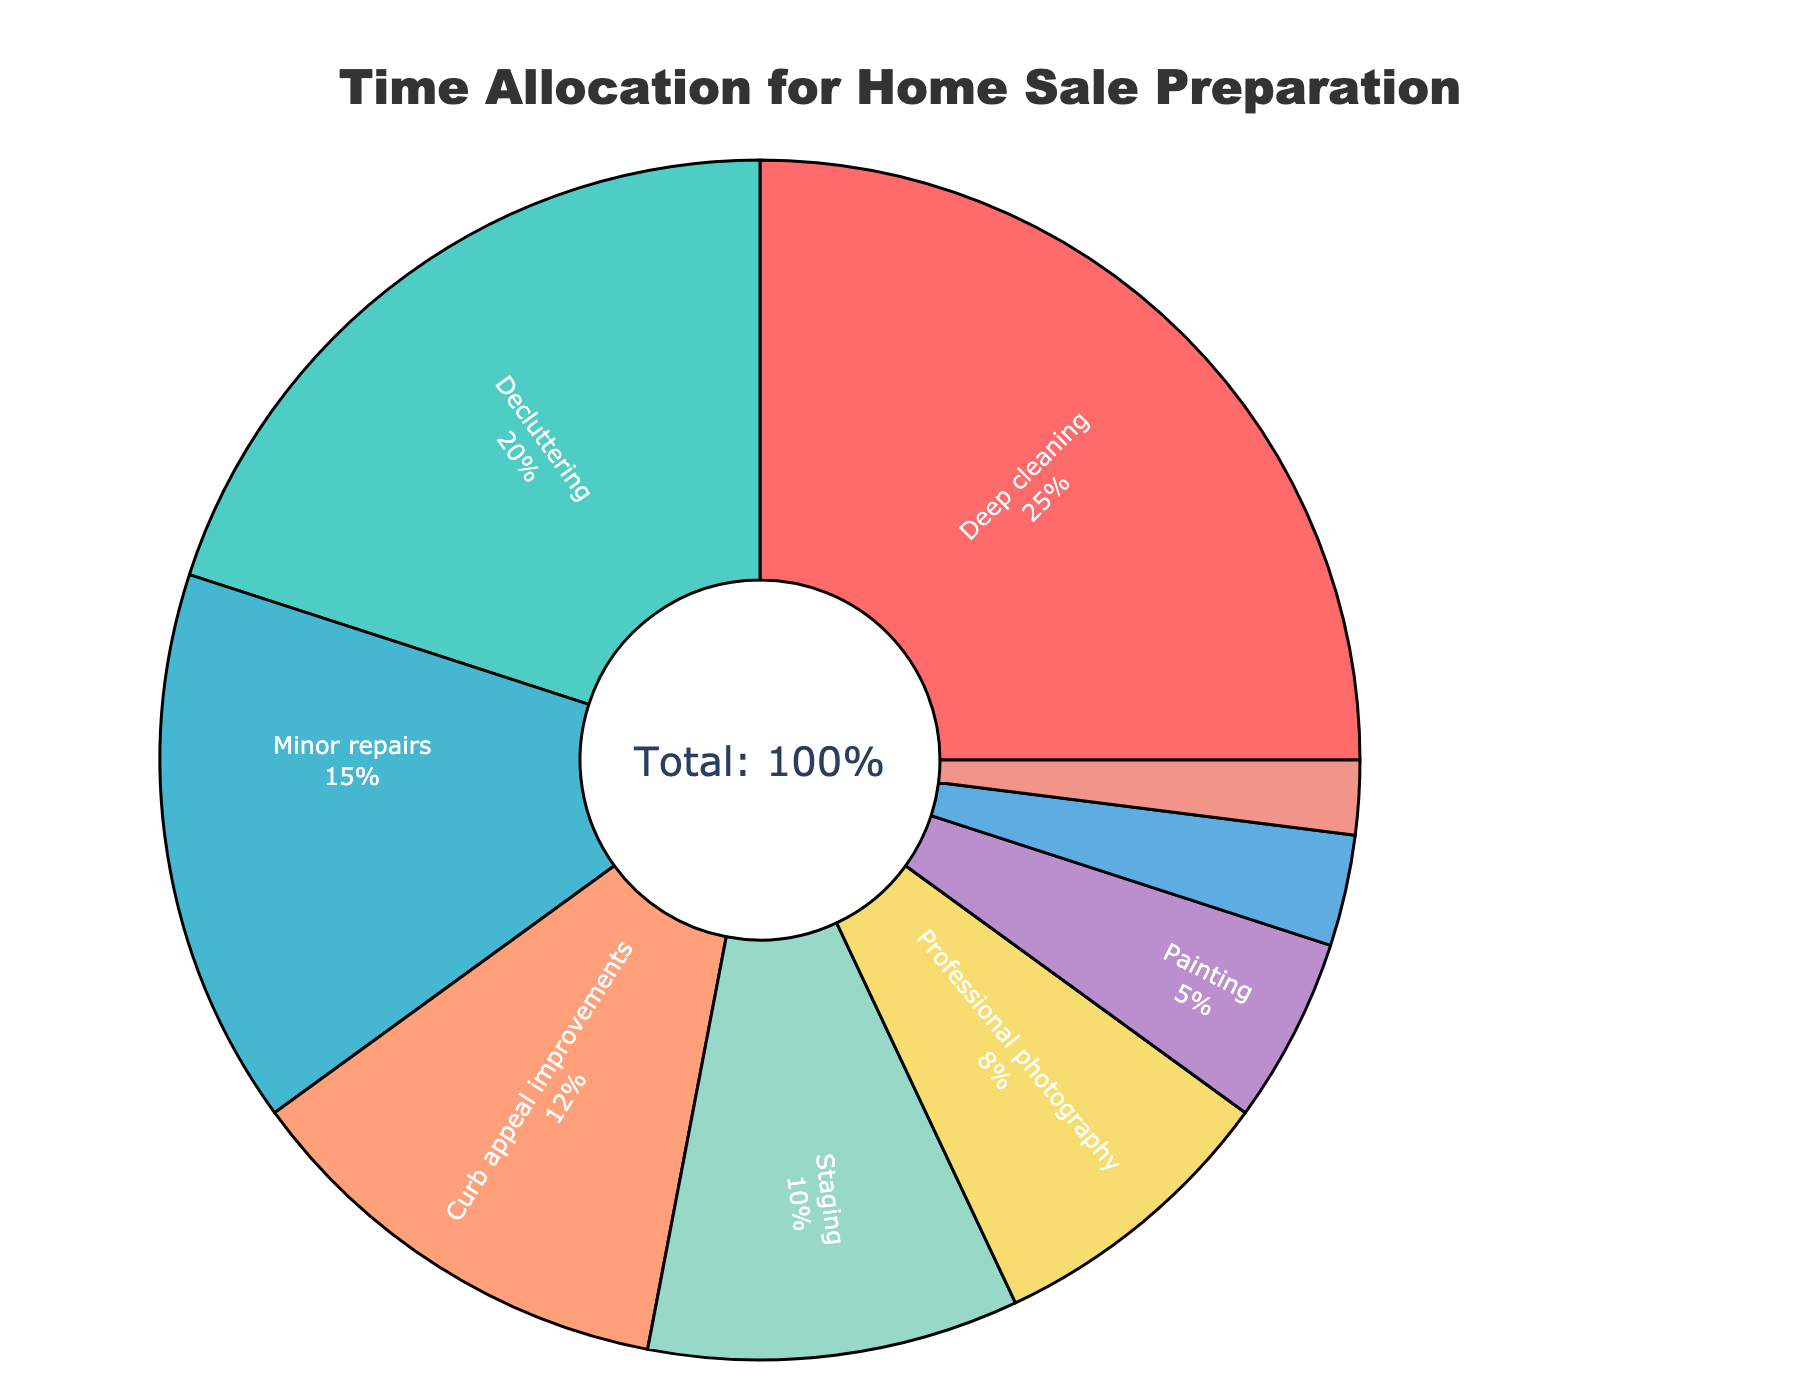What area takes up the largest percentage in home preparation for sale? By looking at the pie chart, the area with the largest percentage slice is easily identifiable due to its size. The "Deep cleaning" slice is the largest.
Answer: Deep cleaning Which area takes more time: staging or painting? Comparing the two slices representing "staging" and "painting", the "staging" slice is larger than the "painting" slice. "Staging" is 10%, while "painting" is 5%.
Answer: Staging What is the total percentage of time spent on tasks not related to cleaning or repairs? First, identify and sum the percentages of areas that are not deep cleaning, decluttering, or minor repairs: Curb appeal improvements (12%) + Staging (10%) + Professional photography (8%) + Painting (5%) + Lighting enhancements (3%) + Neutralizing odors (2%). The total is 12 + 10 + 8 + 5 + 3 + 2 = 40%.
Answer: 40% Which two areas combined take up the same percentage as deep cleaning? Deep cleaning is 25%. Look for two areas whose combined percentages equal 25%. "Decluttering" is 20%, and "Neutralizing odors" is 2%, which totals 22%, so it must be different areas. "Minor repairs" is 15% and "Curb appeal improvements" is 12%, which total 27%, so it is also different. Instead, "Staging" is 10%, and "Professional photography" is 8%, then "Lighting enhancements" is 3%, which makes 21%—still not right. Finally, "Decluttering" (20%) + "Lighting enhancements" (3%) + "Neutralizing odors" (2%) equals 20 + 3 + 2 = 25%.
Answer: Decluttering and Lighting enhancements and Neutralizing odors What is the difference in time allocation between the highest and lowest areas? Identify the highest and lowest slices: Deep cleaning (25%) is the highest, and Neutralizing odors (2%) is the lowest. Calculate the difference: 25% - 2% = 23%.
Answer: 23% Which areas are allocated less than 10% of time? Find slices representing less than 10%: Painting (5%), Lighting enhancements (3%), and Neutralizing odors (2%).
Answer: Painting, Lighting enhancements, Neutralizing odors Is the time spent on curb appeal improvements more than professional photography? Compare the slices representing "Curb appeal improvements" and "Professional photography". "Curb appeal improvements" has 12%, while "Professional photography" has 8%. 12% is greater than 8%.
Answer: Yes If I want to spend equal time on deep cleaning and decluttering combined, which activities should I reduce by half? The total time for deep cleaning (25%) and decluttering (20%) combined is 25 + 20 = 45%. To maintain the total at 100%, reduce the main time-consuming areas proportionally. "Deep cleaning" is 25% and "Decluttering" is 20%, so we would need to reduce by the sum of their excesses. It is 45% - 25% (Deep cleaning is currently this and we need this much space). Reduce equal percentage-wise the highest other activities: Minor repairs (15%), Curb appeal improvements (12%) might be good candidates. Reducing both "Minor repairs" to 7.5% and "Curb appeal improvements" to 6% would equal approximately halving a large part of the difference.
Answer: Reduce Minor repairs and Curb appeal improvements 